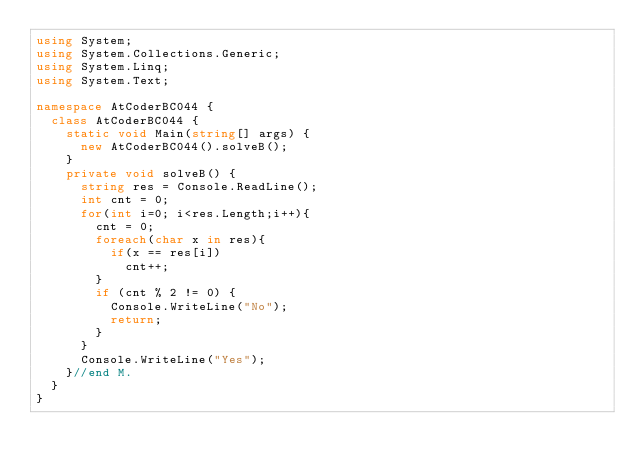<code> <loc_0><loc_0><loc_500><loc_500><_C#_>using System;
using System.Collections.Generic;
using System.Linq;
using System.Text;

namespace AtCoderBC044 {
  class AtCoderBC044 {
    static void Main(string[] args) {
      new AtCoderBC044().solveB();
    }
    private void solveB() {
      string res = Console.ReadLine();
      int cnt = 0;
      for(int i=0; i<res.Length;i++){
        cnt = 0;
        foreach(char x in res){
          if(x == res[i])
            cnt++;
        }
        if (cnt % 2 != 0) {
          Console.WriteLine("No");
          return;
        }
      }      
      Console.WriteLine("Yes");
    }//end M.
  }
}
</code> 